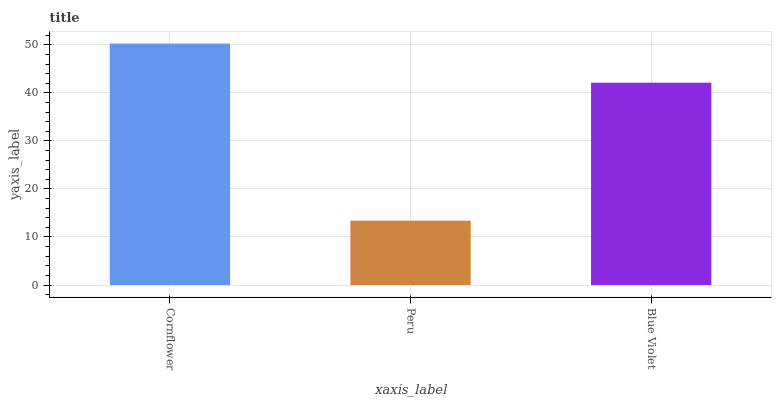Is Blue Violet the minimum?
Answer yes or no. No. Is Blue Violet the maximum?
Answer yes or no. No. Is Blue Violet greater than Peru?
Answer yes or no. Yes. Is Peru less than Blue Violet?
Answer yes or no. Yes. Is Peru greater than Blue Violet?
Answer yes or no. No. Is Blue Violet less than Peru?
Answer yes or no. No. Is Blue Violet the high median?
Answer yes or no. Yes. Is Blue Violet the low median?
Answer yes or no. Yes. Is Peru the high median?
Answer yes or no. No. Is Cornflower the low median?
Answer yes or no. No. 